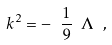<formula> <loc_0><loc_0><loc_500><loc_500>k ^ { 2 } = - \ \frac { 1 } { 9 } \ \Lambda \ ,</formula> 